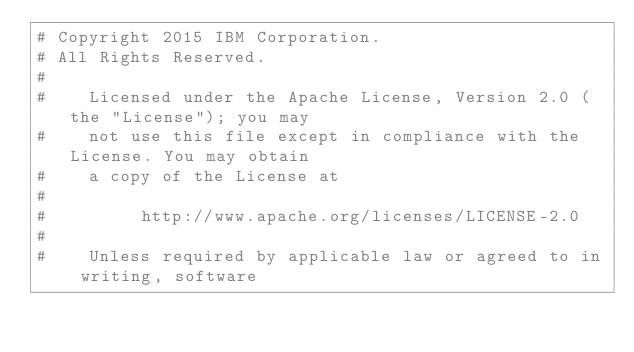Convert code to text. <code><loc_0><loc_0><loc_500><loc_500><_Python_># Copyright 2015 IBM Corporation.
# All Rights Reserved.
#
#    Licensed under the Apache License, Version 2.0 (the "License"); you may
#    not use this file except in compliance with the License. You may obtain
#    a copy of the License at
#
#         http://www.apache.org/licenses/LICENSE-2.0
#
#    Unless required by applicable law or agreed to in writing, software</code> 